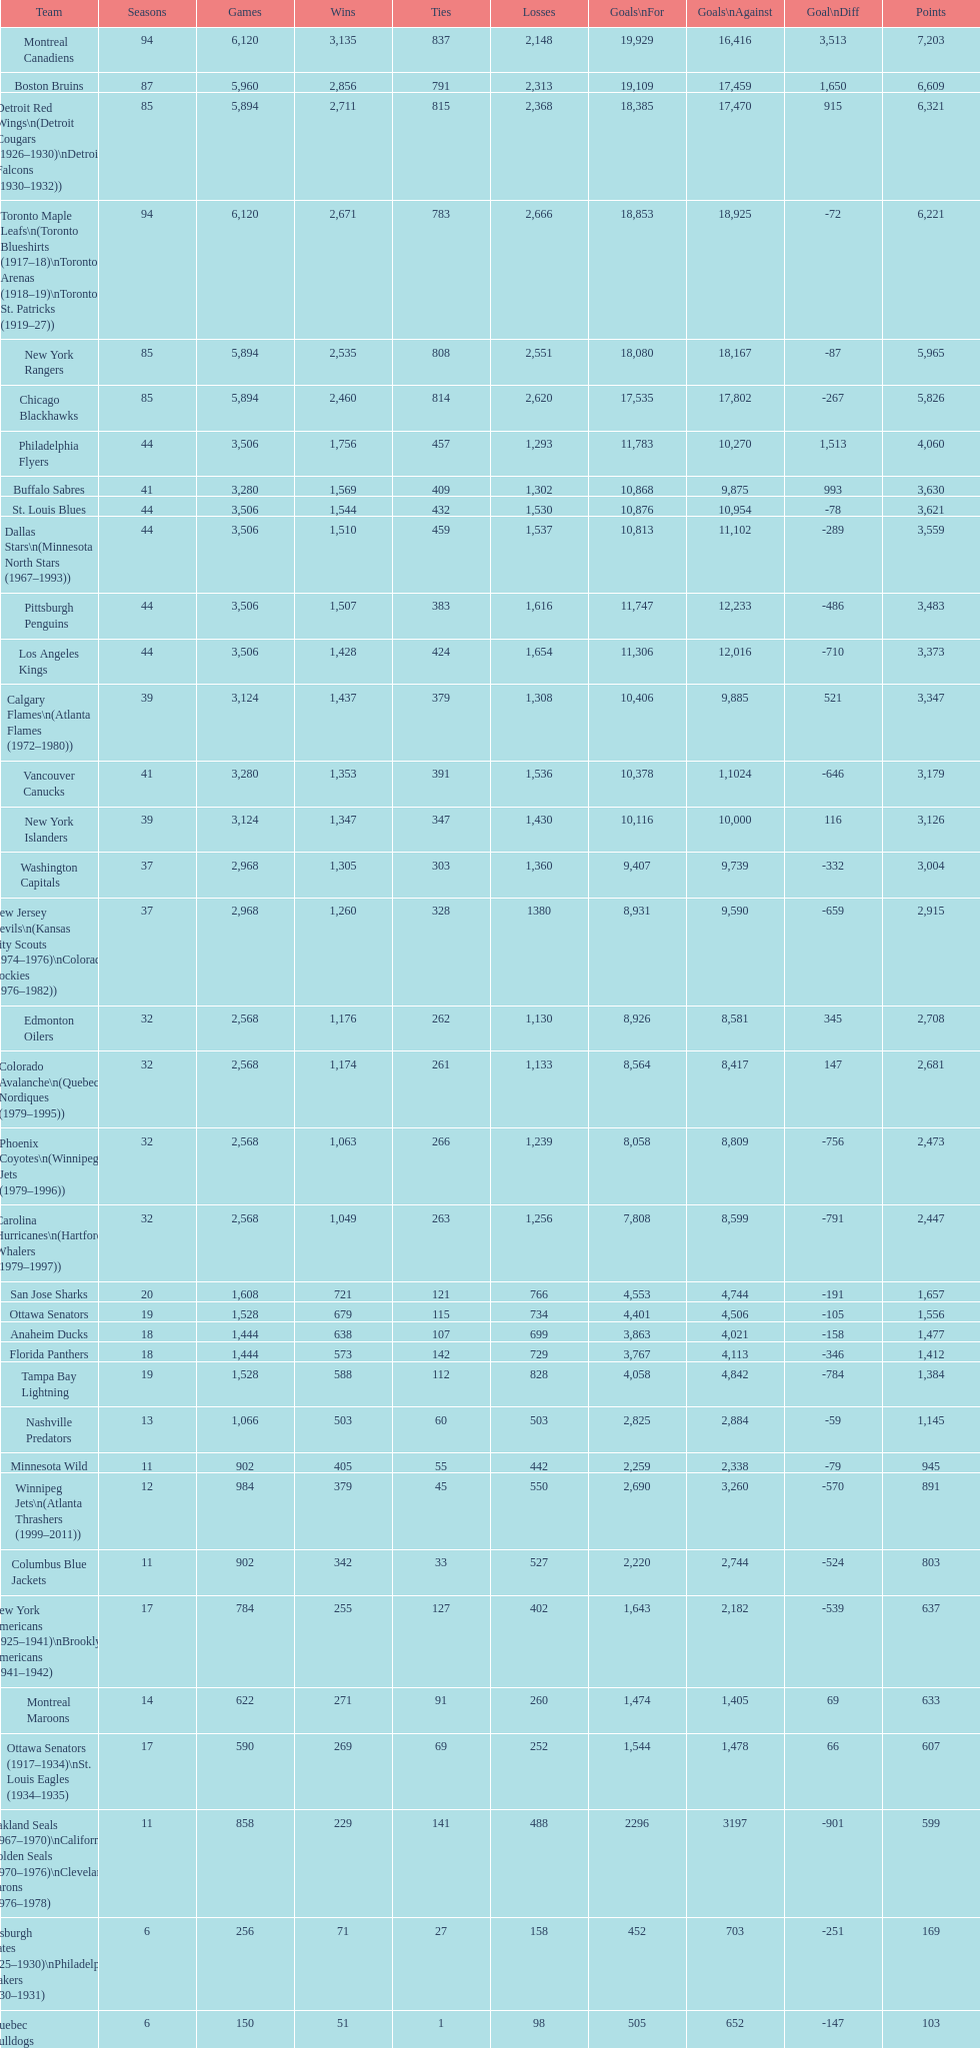Who is at the pinnacle of the list? Montreal Canadiens. 